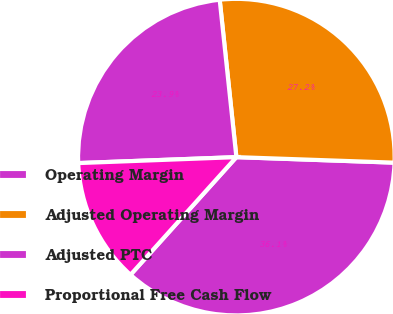Convert chart. <chart><loc_0><loc_0><loc_500><loc_500><pie_chart><fcel>Operating Margin<fcel>Adjusted Operating Margin<fcel>Adjusted PTC<fcel>Proportional Free Cash Flow<nl><fcel>36.11%<fcel>27.24%<fcel>23.92%<fcel>12.74%<nl></chart> 